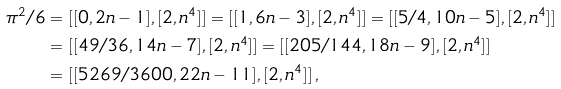Convert formula to latex. <formula><loc_0><loc_0><loc_500><loc_500>\pi ^ { 2 } / 6 & = [ [ 0 , 2 n - 1 ] , [ 2 , n ^ { 4 } ] ] = [ [ 1 , 6 n - 3 ] , [ 2 , n ^ { 4 } ] ] = [ [ 5 / 4 , 1 0 n - 5 ] , [ 2 , n ^ { 4 } ] ] \\ & = [ [ 4 9 / 3 6 , 1 4 n - 7 ] , [ 2 , n ^ { 4 } ] ] = [ [ 2 0 5 / 1 4 4 , 1 8 n - 9 ] , [ 2 , n ^ { 4 } ] ] \\ & = [ [ 5 2 6 9 / 3 6 0 0 , 2 2 n - 1 1 ] , [ 2 , n ^ { 4 } ] ] \, ,</formula> 